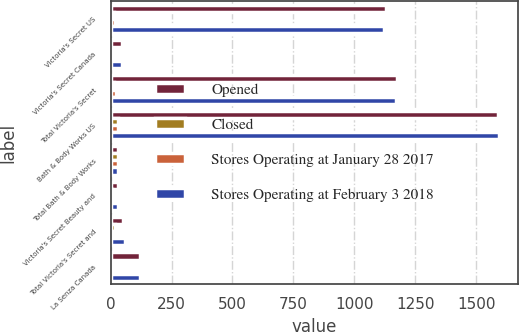Convert chart. <chart><loc_0><loc_0><loc_500><loc_500><stacked_bar_chart><ecel><fcel>Victoria's Secret US<fcel>Victoria's Secret Canada<fcel>Total Victoria's Secret<fcel>Bath & Body Works US<fcel>Total Bath & Body Works<fcel>Victoria's Secret Beauty and<fcel>Total Victoria's Secret and<fcel>La Senza Canada<nl><fcel>Opened<fcel>1131<fcel>46<fcel>1177<fcel>1591<fcel>31<fcel>31<fcel>49<fcel>122<nl><fcel>Closed<fcel>13<fcel>2<fcel>15<fcel>32<fcel>32<fcel>4<fcel>17<fcel>1<nl><fcel>Stores Operating at January 28 2017<fcel>20<fcel>2<fcel>22<fcel>31<fcel>31<fcel>6<fcel>6<fcel>4<nl><fcel>Stores Operating at February 3 2018<fcel>1124<fcel>46<fcel>1170<fcel>1592<fcel>31<fcel>29<fcel>60<fcel>119<nl></chart> 